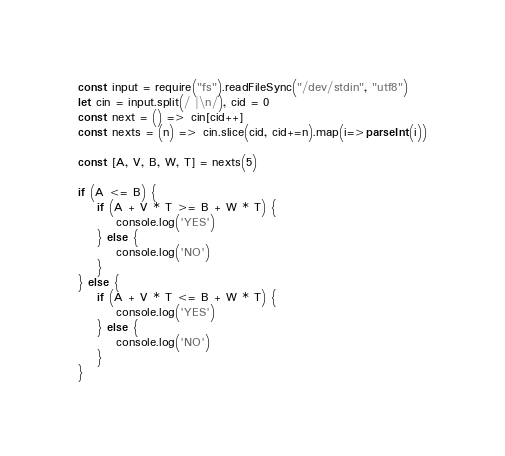<code> <loc_0><loc_0><loc_500><loc_500><_JavaScript_>const input = require("fs").readFileSync("/dev/stdin", "utf8")
let cin = input.split(/ |\n/), cid = 0
const next = () => cin[cid++]
const nexts = (n) => cin.slice(cid, cid+=n).map(i=>parseInt(i))

const [A, V, B, W, T] = nexts(5)

if (A <= B) {
    if (A + V * T >= B + W * T) {
        console.log('YES')
    } else {
        console.log('NO')
    }
} else {
    if (A + V * T <= B + W * T) {
        console.log('YES')
    } else {
        console.log('NO')
    }
}
</code> 